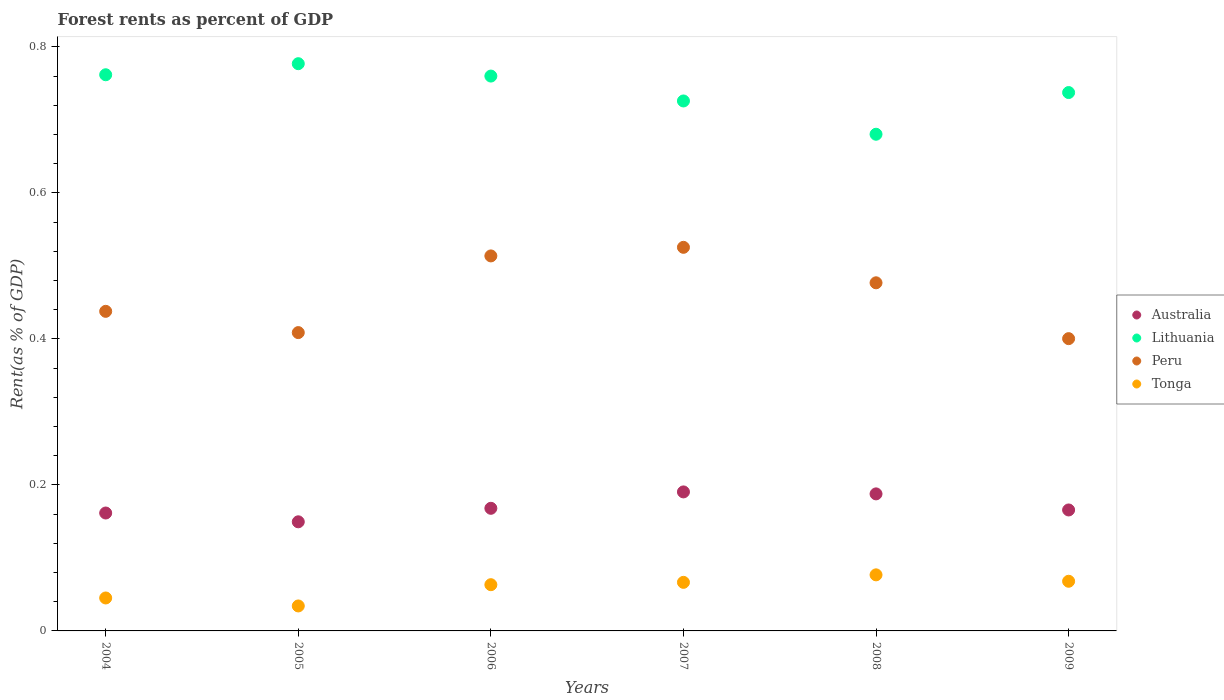What is the forest rent in Lithuania in 2009?
Provide a succinct answer. 0.74. Across all years, what is the maximum forest rent in Lithuania?
Provide a succinct answer. 0.78. Across all years, what is the minimum forest rent in Tonga?
Make the answer very short. 0.03. What is the total forest rent in Peru in the graph?
Offer a very short reply. 2.76. What is the difference between the forest rent in Australia in 2006 and that in 2008?
Give a very brief answer. -0.02. What is the difference between the forest rent in Tonga in 2006 and the forest rent in Peru in 2005?
Ensure brevity in your answer.  -0.35. What is the average forest rent in Lithuania per year?
Make the answer very short. 0.74. In the year 2006, what is the difference between the forest rent in Peru and forest rent in Lithuania?
Keep it short and to the point. -0.25. In how many years, is the forest rent in Lithuania greater than 0.56 %?
Keep it short and to the point. 6. What is the ratio of the forest rent in Australia in 2004 to that in 2007?
Provide a short and direct response. 0.85. Is the forest rent in Tonga in 2005 less than that in 2007?
Make the answer very short. Yes. Is the difference between the forest rent in Peru in 2004 and 2006 greater than the difference between the forest rent in Lithuania in 2004 and 2006?
Offer a terse response. No. What is the difference between the highest and the second highest forest rent in Australia?
Ensure brevity in your answer.  0. What is the difference between the highest and the lowest forest rent in Peru?
Your response must be concise. 0.13. In how many years, is the forest rent in Australia greater than the average forest rent in Australia taken over all years?
Offer a terse response. 2. Is the sum of the forest rent in Tonga in 2005 and 2009 greater than the maximum forest rent in Peru across all years?
Your answer should be compact. No. How many dotlines are there?
Offer a terse response. 4. How many years are there in the graph?
Your answer should be compact. 6. What is the difference between two consecutive major ticks on the Y-axis?
Your answer should be compact. 0.2. Are the values on the major ticks of Y-axis written in scientific E-notation?
Give a very brief answer. No. Does the graph contain grids?
Make the answer very short. No. Where does the legend appear in the graph?
Make the answer very short. Center right. What is the title of the graph?
Make the answer very short. Forest rents as percent of GDP. Does "Guam" appear as one of the legend labels in the graph?
Ensure brevity in your answer.  No. What is the label or title of the X-axis?
Your answer should be very brief. Years. What is the label or title of the Y-axis?
Your response must be concise. Rent(as % of GDP). What is the Rent(as % of GDP) of Australia in 2004?
Provide a short and direct response. 0.16. What is the Rent(as % of GDP) in Lithuania in 2004?
Your answer should be compact. 0.76. What is the Rent(as % of GDP) in Peru in 2004?
Your response must be concise. 0.44. What is the Rent(as % of GDP) in Tonga in 2004?
Your answer should be compact. 0.05. What is the Rent(as % of GDP) of Australia in 2005?
Your response must be concise. 0.15. What is the Rent(as % of GDP) of Lithuania in 2005?
Your answer should be compact. 0.78. What is the Rent(as % of GDP) in Peru in 2005?
Your answer should be very brief. 0.41. What is the Rent(as % of GDP) in Tonga in 2005?
Ensure brevity in your answer.  0.03. What is the Rent(as % of GDP) in Australia in 2006?
Provide a short and direct response. 0.17. What is the Rent(as % of GDP) of Lithuania in 2006?
Offer a terse response. 0.76. What is the Rent(as % of GDP) in Peru in 2006?
Offer a very short reply. 0.51. What is the Rent(as % of GDP) of Tonga in 2006?
Offer a very short reply. 0.06. What is the Rent(as % of GDP) in Australia in 2007?
Provide a short and direct response. 0.19. What is the Rent(as % of GDP) of Lithuania in 2007?
Keep it short and to the point. 0.73. What is the Rent(as % of GDP) of Peru in 2007?
Offer a terse response. 0.53. What is the Rent(as % of GDP) in Tonga in 2007?
Your answer should be very brief. 0.07. What is the Rent(as % of GDP) of Australia in 2008?
Ensure brevity in your answer.  0.19. What is the Rent(as % of GDP) of Lithuania in 2008?
Keep it short and to the point. 0.68. What is the Rent(as % of GDP) of Peru in 2008?
Make the answer very short. 0.48. What is the Rent(as % of GDP) in Tonga in 2008?
Ensure brevity in your answer.  0.08. What is the Rent(as % of GDP) in Australia in 2009?
Give a very brief answer. 0.17. What is the Rent(as % of GDP) in Lithuania in 2009?
Ensure brevity in your answer.  0.74. What is the Rent(as % of GDP) in Peru in 2009?
Provide a short and direct response. 0.4. What is the Rent(as % of GDP) in Tonga in 2009?
Offer a terse response. 0.07. Across all years, what is the maximum Rent(as % of GDP) of Australia?
Ensure brevity in your answer.  0.19. Across all years, what is the maximum Rent(as % of GDP) in Lithuania?
Offer a very short reply. 0.78. Across all years, what is the maximum Rent(as % of GDP) of Peru?
Offer a very short reply. 0.53. Across all years, what is the maximum Rent(as % of GDP) of Tonga?
Your answer should be very brief. 0.08. Across all years, what is the minimum Rent(as % of GDP) of Australia?
Give a very brief answer. 0.15. Across all years, what is the minimum Rent(as % of GDP) of Lithuania?
Ensure brevity in your answer.  0.68. Across all years, what is the minimum Rent(as % of GDP) of Peru?
Keep it short and to the point. 0.4. Across all years, what is the minimum Rent(as % of GDP) of Tonga?
Ensure brevity in your answer.  0.03. What is the total Rent(as % of GDP) of Australia in the graph?
Ensure brevity in your answer.  1.02. What is the total Rent(as % of GDP) of Lithuania in the graph?
Give a very brief answer. 4.44. What is the total Rent(as % of GDP) in Peru in the graph?
Provide a short and direct response. 2.76. What is the total Rent(as % of GDP) of Tonga in the graph?
Keep it short and to the point. 0.35. What is the difference between the Rent(as % of GDP) of Australia in 2004 and that in 2005?
Ensure brevity in your answer.  0.01. What is the difference between the Rent(as % of GDP) of Lithuania in 2004 and that in 2005?
Provide a succinct answer. -0.02. What is the difference between the Rent(as % of GDP) of Peru in 2004 and that in 2005?
Your response must be concise. 0.03. What is the difference between the Rent(as % of GDP) of Tonga in 2004 and that in 2005?
Provide a short and direct response. 0.01. What is the difference between the Rent(as % of GDP) in Australia in 2004 and that in 2006?
Your answer should be very brief. -0.01. What is the difference between the Rent(as % of GDP) in Lithuania in 2004 and that in 2006?
Your response must be concise. 0. What is the difference between the Rent(as % of GDP) in Peru in 2004 and that in 2006?
Your answer should be very brief. -0.08. What is the difference between the Rent(as % of GDP) in Tonga in 2004 and that in 2006?
Offer a terse response. -0.02. What is the difference between the Rent(as % of GDP) in Australia in 2004 and that in 2007?
Your answer should be very brief. -0.03. What is the difference between the Rent(as % of GDP) of Lithuania in 2004 and that in 2007?
Offer a very short reply. 0.04. What is the difference between the Rent(as % of GDP) of Peru in 2004 and that in 2007?
Provide a short and direct response. -0.09. What is the difference between the Rent(as % of GDP) of Tonga in 2004 and that in 2007?
Give a very brief answer. -0.02. What is the difference between the Rent(as % of GDP) of Australia in 2004 and that in 2008?
Provide a short and direct response. -0.03. What is the difference between the Rent(as % of GDP) in Lithuania in 2004 and that in 2008?
Offer a very short reply. 0.08. What is the difference between the Rent(as % of GDP) in Peru in 2004 and that in 2008?
Provide a succinct answer. -0.04. What is the difference between the Rent(as % of GDP) in Tonga in 2004 and that in 2008?
Your response must be concise. -0.03. What is the difference between the Rent(as % of GDP) of Australia in 2004 and that in 2009?
Your answer should be very brief. -0. What is the difference between the Rent(as % of GDP) in Lithuania in 2004 and that in 2009?
Give a very brief answer. 0.02. What is the difference between the Rent(as % of GDP) of Peru in 2004 and that in 2009?
Your answer should be compact. 0.04. What is the difference between the Rent(as % of GDP) in Tonga in 2004 and that in 2009?
Offer a very short reply. -0.02. What is the difference between the Rent(as % of GDP) of Australia in 2005 and that in 2006?
Provide a succinct answer. -0.02. What is the difference between the Rent(as % of GDP) in Lithuania in 2005 and that in 2006?
Ensure brevity in your answer.  0.02. What is the difference between the Rent(as % of GDP) in Peru in 2005 and that in 2006?
Make the answer very short. -0.1. What is the difference between the Rent(as % of GDP) in Tonga in 2005 and that in 2006?
Provide a succinct answer. -0.03. What is the difference between the Rent(as % of GDP) of Australia in 2005 and that in 2007?
Offer a terse response. -0.04. What is the difference between the Rent(as % of GDP) of Lithuania in 2005 and that in 2007?
Your answer should be compact. 0.05. What is the difference between the Rent(as % of GDP) of Peru in 2005 and that in 2007?
Your response must be concise. -0.12. What is the difference between the Rent(as % of GDP) of Tonga in 2005 and that in 2007?
Give a very brief answer. -0.03. What is the difference between the Rent(as % of GDP) in Australia in 2005 and that in 2008?
Your response must be concise. -0.04. What is the difference between the Rent(as % of GDP) of Lithuania in 2005 and that in 2008?
Your answer should be compact. 0.1. What is the difference between the Rent(as % of GDP) in Peru in 2005 and that in 2008?
Your response must be concise. -0.07. What is the difference between the Rent(as % of GDP) in Tonga in 2005 and that in 2008?
Your response must be concise. -0.04. What is the difference between the Rent(as % of GDP) in Australia in 2005 and that in 2009?
Give a very brief answer. -0.02. What is the difference between the Rent(as % of GDP) of Lithuania in 2005 and that in 2009?
Offer a very short reply. 0.04. What is the difference between the Rent(as % of GDP) in Peru in 2005 and that in 2009?
Make the answer very short. 0.01. What is the difference between the Rent(as % of GDP) in Tonga in 2005 and that in 2009?
Offer a terse response. -0.03. What is the difference between the Rent(as % of GDP) of Australia in 2006 and that in 2007?
Keep it short and to the point. -0.02. What is the difference between the Rent(as % of GDP) in Lithuania in 2006 and that in 2007?
Ensure brevity in your answer.  0.03. What is the difference between the Rent(as % of GDP) of Peru in 2006 and that in 2007?
Provide a succinct answer. -0.01. What is the difference between the Rent(as % of GDP) in Tonga in 2006 and that in 2007?
Ensure brevity in your answer.  -0. What is the difference between the Rent(as % of GDP) of Australia in 2006 and that in 2008?
Your response must be concise. -0.02. What is the difference between the Rent(as % of GDP) in Lithuania in 2006 and that in 2008?
Ensure brevity in your answer.  0.08. What is the difference between the Rent(as % of GDP) of Peru in 2006 and that in 2008?
Offer a terse response. 0.04. What is the difference between the Rent(as % of GDP) of Tonga in 2006 and that in 2008?
Give a very brief answer. -0.01. What is the difference between the Rent(as % of GDP) in Australia in 2006 and that in 2009?
Offer a terse response. 0. What is the difference between the Rent(as % of GDP) of Lithuania in 2006 and that in 2009?
Give a very brief answer. 0.02. What is the difference between the Rent(as % of GDP) of Peru in 2006 and that in 2009?
Your answer should be compact. 0.11. What is the difference between the Rent(as % of GDP) of Tonga in 2006 and that in 2009?
Offer a very short reply. -0. What is the difference between the Rent(as % of GDP) of Australia in 2007 and that in 2008?
Your answer should be compact. 0. What is the difference between the Rent(as % of GDP) in Lithuania in 2007 and that in 2008?
Offer a very short reply. 0.05. What is the difference between the Rent(as % of GDP) of Peru in 2007 and that in 2008?
Give a very brief answer. 0.05. What is the difference between the Rent(as % of GDP) of Tonga in 2007 and that in 2008?
Provide a succinct answer. -0.01. What is the difference between the Rent(as % of GDP) in Australia in 2007 and that in 2009?
Make the answer very short. 0.02. What is the difference between the Rent(as % of GDP) of Lithuania in 2007 and that in 2009?
Your response must be concise. -0.01. What is the difference between the Rent(as % of GDP) of Peru in 2007 and that in 2009?
Make the answer very short. 0.13. What is the difference between the Rent(as % of GDP) in Tonga in 2007 and that in 2009?
Provide a succinct answer. -0. What is the difference between the Rent(as % of GDP) in Australia in 2008 and that in 2009?
Your answer should be very brief. 0.02. What is the difference between the Rent(as % of GDP) in Lithuania in 2008 and that in 2009?
Provide a short and direct response. -0.06. What is the difference between the Rent(as % of GDP) of Peru in 2008 and that in 2009?
Keep it short and to the point. 0.08. What is the difference between the Rent(as % of GDP) in Tonga in 2008 and that in 2009?
Offer a very short reply. 0.01. What is the difference between the Rent(as % of GDP) in Australia in 2004 and the Rent(as % of GDP) in Lithuania in 2005?
Keep it short and to the point. -0.62. What is the difference between the Rent(as % of GDP) in Australia in 2004 and the Rent(as % of GDP) in Peru in 2005?
Provide a short and direct response. -0.25. What is the difference between the Rent(as % of GDP) in Australia in 2004 and the Rent(as % of GDP) in Tonga in 2005?
Your answer should be very brief. 0.13. What is the difference between the Rent(as % of GDP) of Lithuania in 2004 and the Rent(as % of GDP) of Peru in 2005?
Make the answer very short. 0.35. What is the difference between the Rent(as % of GDP) of Lithuania in 2004 and the Rent(as % of GDP) of Tonga in 2005?
Provide a short and direct response. 0.73. What is the difference between the Rent(as % of GDP) in Peru in 2004 and the Rent(as % of GDP) in Tonga in 2005?
Your response must be concise. 0.4. What is the difference between the Rent(as % of GDP) in Australia in 2004 and the Rent(as % of GDP) in Lithuania in 2006?
Provide a short and direct response. -0.6. What is the difference between the Rent(as % of GDP) in Australia in 2004 and the Rent(as % of GDP) in Peru in 2006?
Provide a succinct answer. -0.35. What is the difference between the Rent(as % of GDP) in Australia in 2004 and the Rent(as % of GDP) in Tonga in 2006?
Your answer should be very brief. 0.1. What is the difference between the Rent(as % of GDP) in Lithuania in 2004 and the Rent(as % of GDP) in Peru in 2006?
Ensure brevity in your answer.  0.25. What is the difference between the Rent(as % of GDP) of Lithuania in 2004 and the Rent(as % of GDP) of Tonga in 2006?
Keep it short and to the point. 0.7. What is the difference between the Rent(as % of GDP) in Peru in 2004 and the Rent(as % of GDP) in Tonga in 2006?
Your response must be concise. 0.37. What is the difference between the Rent(as % of GDP) of Australia in 2004 and the Rent(as % of GDP) of Lithuania in 2007?
Your answer should be very brief. -0.56. What is the difference between the Rent(as % of GDP) of Australia in 2004 and the Rent(as % of GDP) of Peru in 2007?
Offer a terse response. -0.36. What is the difference between the Rent(as % of GDP) in Australia in 2004 and the Rent(as % of GDP) in Tonga in 2007?
Your answer should be compact. 0.1. What is the difference between the Rent(as % of GDP) of Lithuania in 2004 and the Rent(as % of GDP) of Peru in 2007?
Provide a short and direct response. 0.24. What is the difference between the Rent(as % of GDP) in Lithuania in 2004 and the Rent(as % of GDP) in Tonga in 2007?
Keep it short and to the point. 0.7. What is the difference between the Rent(as % of GDP) in Peru in 2004 and the Rent(as % of GDP) in Tonga in 2007?
Your answer should be compact. 0.37. What is the difference between the Rent(as % of GDP) in Australia in 2004 and the Rent(as % of GDP) in Lithuania in 2008?
Your answer should be very brief. -0.52. What is the difference between the Rent(as % of GDP) of Australia in 2004 and the Rent(as % of GDP) of Peru in 2008?
Your response must be concise. -0.32. What is the difference between the Rent(as % of GDP) of Australia in 2004 and the Rent(as % of GDP) of Tonga in 2008?
Your answer should be compact. 0.08. What is the difference between the Rent(as % of GDP) of Lithuania in 2004 and the Rent(as % of GDP) of Peru in 2008?
Ensure brevity in your answer.  0.28. What is the difference between the Rent(as % of GDP) of Lithuania in 2004 and the Rent(as % of GDP) of Tonga in 2008?
Keep it short and to the point. 0.69. What is the difference between the Rent(as % of GDP) in Peru in 2004 and the Rent(as % of GDP) in Tonga in 2008?
Offer a terse response. 0.36. What is the difference between the Rent(as % of GDP) of Australia in 2004 and the Rent(as % of GDP) of Lithuania in 2009?
Your answer should be compact. -0.58. What is the difference between the Rent(as % of GDP) in Australia in 2004 and the Rent(as % of GDP) in Peru in 2009?
Keep it short and to the point. -0.24. What is the difference between the Rent(as % of GDP) in Australia in 2004 and the Rent(as % of GDP) in Tonga in 2009?
Your answer should be compact. 0.09. What is the difference between the Rent(as % of GDP) of Lithuania in 2004 and the Rent(as % of GDP) of Peru in 2009?
Ensure brevity in your answer.  0.36. What is the difference between the Rent(as % of GDP) of Lithuania in 2004 and the Rent(as % of GDP) of Tonga in 2009?
Give a very brief answer. 0.69. What is the difference between the Rent(as % of GDP) of Peru in 2004 and the Rent(as % of GDP) of Tonga in 2009?
Give a very brief answer. 0.37. What is the difference between the Rent(as % of GDP) of Australia in 2005 and the Rent(as % of GDP) of Lithuania in 2006?
Keep it short and to the point. -0.61. What is the difference between the Rent(as % of GDP) of Australia in 2005 and the Rent(as % of GDP) of Peru in 2006?
Ensure brevity in your answer.  -0.36. What is the difference between the Rent(as % of GDP) in Australia in 2005 and the Rent(as % of GDP) in Tonga in 2006?
Ensure brevity in your answer.  0.09. What is the difference between the Rent(as % of GDP) in Lithuania in 2005 and the Rent(as % of GDP) in Peru in 2006?
Keep it short and to the point. 0.26. What is the difference between the Rent(as % of GDP) of Lithuania in 2005 and the Rent(as % of GDP) of Tonga in 2006?
Provide a succinct answer. 0.71. What is the difference between the Rent(as % of GDP) in Peru in 2005 and the Rent(as % of GDP) in Tonga in 2006?
Provide a short and direct response. 0.35. What is the difference between the Rent(as % of GDP) of Australia in 2005 and the Rent(as % of GDP) of Lithuania in 2007?
Make the answer very short. -0.58. What is the difference between the Rent(as % of GDP) in Australia in 2005 and the Rent(as % of GDP) in Peru in 2007?
Make the answer very short. -0.38. What is the difference between the Rent(as % of GDP) in Australia in 2005 and the Rent(as % of GDP) in Tonga in 2007?
Your answer should be very brief. 0.08. What is the difference between the Rent(as % of GDP) in Lithuania in 2005 and the Rent(as % of GDP) in Peru in 2007?
Offer a terse response. 0.25. What is the difference between the Rent(as % of GDP) in Lithuania in 2005 and the Rent(as % of GDP) in Tonga in 2007?
Your response must be concise. 0.71. What is the difference between the Rent(as % of GDP) of Peru in 2005 and the Rent(as % of GDP) of Tonga in 2007?
Provide a succinct answer. 0.34. What is the difference between the Rent(as % of GDP) in Australia in 2005 and the Rent(as % of GDP) in Lithuania in 2008?
Make the answer very short. -0.53. What is the difference between the Rent(as % of GDP) of Australia in 2005 and the Rent(as % of GDP) of Peru in 2008?
Your answer should be very brief. -0.33. What is the difference between the Rent(as % of GDP) in Australia in 2005 and the Rent(as % of GDP) in Tonga in 2008?
Offer a terse response. 0.07. What is the difference between the Rent(as % of GDP) of Lithuania in 2005 and the Rent(as % of GDP) of Peru in 2008?
Your answer should be compact. 0.3. What is the difference between the Rent(as % of GDP) of Lithuania in 2005 and the Rent(as % of GDP) of Tonga in 2008?
Ensure brevity in your answer.  0.7. What is the difference between the Rent(as % of GDP) of Peru in 2005 and the Rent(as % of GDP) of Tonga in 2008?
Provide a succinct answer. 0.33. What is the difference between the Rent(as % of GDP) of Australia in 2005 and the Rent(as % of GDP) of Lithuania in 2009?
Give a very brief answer. -0.59. What is the difference between the Rent(as % of GDP) in Australia in 2005 and the Rent(as % of GDP) in Peru in 2009?
Give a very brief answer. -0.25. What is the difference between the Rent(as % of GDP) in Australia in 2005 and the Rent(as % of GDP) in Tonga in 2009?
Your response must be concise. 0.08. What is the difference between the Rent(as % of GDP) of Lithuania in 2005 and the Rent(as % of GDP) of Peru in 2009?
Ensure brevity in your answer.  0.38. What is the difference between the Rent(as % of GDP) in Lithuania in 2005 and the Rent(as % of GDP) in Tonga in 2009?
Ensure brevity in your answer.  0.71. What is the difference between the Rent(as % of GDP) in Peru in 2005 and the Rent(as % of GDP) in Tonga in 2009?
Your answer should be compact. 0.34. What is the difference between the Rent(as % of GDP) in Australia in 2006 and the Rent(as % of GDP) in Lithuania in 2007?
Provide a short and direct response. -0.56. What is the difference between the Rent(as % of GDP) of Australia in 2006 and the Rent(as % of GDP) of Peru in 2007?
Provide a short and direct response. -0.36. What is the difference between the Rent(as % of GDP) of Australia in 2006 and the Rent(as % of GDP) of Tonga in 2007?
Provide a succinct answer. 0.1. What is the difference between the Rent(as % of GDP) in Lithuania in 2006 and the Rent(as % of GDP) in Peru in 2007?
Provide a succinct answer. 0.23. What is the difference between the Rent(as % of GDP) in Lithuania in 2006 and the Rent(as % of GDP) in Tonga in 2007?
Make the answer very short. 0.69. What is the difference between the Rent(as % of GDP) in Peru in 2006 and the Rent(as % of GDP) in Tonga in 2007?
Provide a short and direct response. 0.45. What is the difference between the Rent(as % of GDP) in Australia in 2006 and the Rent(as % of GDP) in Lithuania in 2008?
Offer a very short reply. -0.51. What is the difference between the Rent(as % of GDP) of Australia in 2006 and the Rent(as % of GDP) of Peru in 2008?
Offer a terse response. -0.31. What is the difference between the Rent(as % of GDP) in Australia in 2006 and the Rent(as % of GDP) in Tonga in 2008?
Your answer should be very brief. 0.09. What is the difference between the Rent(as % of GDP) of Lithuania in 2006 and the Rent(as % of GDP) of Peru in 2008?
Provide a succinct answer. 0.28. What is the difference between the Rent(as % of GDP) of Lithuania in 2006 and the Rent(as % of GDP) of Tonga in 2008?
Your answer should be compact. 0.68. What is the difference between the Rent(as % of GDP) in Peru in 2006 and the Rent(as % of GDP) in Tonga in 2008?
Keep it short and to the point. 0.44. What is the difference between the Rent(as % of GDP) in Australia in 2006 and the Rent(as % of GDP) in Lithuania in 2009?
Provide a short and direct response. -0.57. What is the difference between the Rent(as % of GDP) in Australia in 2006 and the Rent(as % of GDP) in Peru in 2009?
Ensure brevity in your answer.  -0.23. What is the difference between the Rent(as % of GDP) of Australia in 2006 and the Rent(as % of GDP) of Tonga in 2009?
Your response must be concise. 0.1. What is the difference between the Rent(as % of GDP) in Lithuania in 2006 and the Rent(as % of GDP) in Peru in 2009?
Make the answer very short. 0.36. What is the difference between the Rent(as % of GDP) in Lithuania in 2006 and the Rent(as % of GDP) in Tonga in 2009?
Keep it short and to the point. 0.69. What is the difference between the Rent(as % of GDP) of Peru in 2006 and the Rent(as % of GDP) of Tonga in 2009?
Ensure brevity in your answer.  0.45. What is the difference between the Rent(as % of GDP) in Australia in 2007 and the Rent(as % of GDP) in Lithuania in 2008?
Ensure brevity in your answer.  -0.49. What is the difference between the Rent(as % of GDP) of Australia in 2007 and the Rent(as % of GDP) of Peru in 2008?
Your answer should be compact. -0.29. What is the difference between the Rent(as % of GDP) in Australia in 2007 and the Rent(as % of GDP) in Tonga in 2008?
Your answer should be very brief. 0.11. What is the difference between the Rent(as % of GDP) of Lithuania in 2007 and the Rent(as % of GDP) of Peru in 2008?
Make the answer very short. 0.25. What is the difference between the Rent(as % of GDP) in Lithuania in 2007 and the Rent(as % of GDP) in Tonga in 2008?
Provide a succinct answer. 0.65. What is the difference between the Rent(as % of GDP) of Peru in 2007 and the Rent(as % of GDP) of Tonga in 2008?
Keep it short and to the point. 0.45. What is the difference between the Rent(as % of GDP) of Australia in 2007 and the Rent(as % of GDP) of Lithuania in 2009?
Your answer should be very brief. -0.55. What is the difference between the Rent(as % of GDP) of Australia in 2007 and the Rent(as % of GDP) of Peru in 2009?
Keep it short and to the point. -0.21. What is the difference between the Rent(as % of GDP) in Australia in 2007 and the Rent(as % of GDP) in Tonga in 2009?
Your answer should be very brief. 0.12. What is the difference between the Rent(as % of GDP) in Lithuania in 2007 and the Rent(as % of GDP) in Peru in 2009?
Your answer should be very brief. 0.33. What is the difference between the Rent(as % of GDP) in Lithuania in 2007 and the Rent(as % of GDP) in Tonga in 2009?
Provide a succinct answer. 0.66. What is the difference between the Rent(as % of GDP) of Peru in 2007 and the Rent(as % of GDP) of Tonga in 2009?
Keep it short and to the point. 0.46. What is the difference between the Rent(as % of GDP) in Australia in 2008 and the Rent(as % of GDP) in Lithuania in 2009?
Give a very brief answer. -0.55. What is the difference between the Rent(as % of GDP) in Australia in 2008 and the Rent(as % of GDP) in Peru in 2009?
Give a very brief answer. -0.21. What is the difference between the Rent(as % of GDP) in Australia in 2008 and the Rent(as % of GDP) in Tonga in 2009?
Give a very brief answer. 0.12. What is the difference between the Rent(as % of GDP) in Lithuania in 2008 and the Rent(as % of GDP) in Peru in 2009?
Provide a short and direct response. 0.28. What is the difference between the Rent(as % of GDP) of Lithuania in 2008 and the Rent(as % of GDP) of Tonga in 2009?
Your answer should be very brief. 0.61. What is the difference between the Rent(as % of GDP) in Peru in 2008 and the Rent(as % of GDP) in Tonga in 2009?
Provide a short and direct response. 0.41. What is the average Rent(as % of GDP) of Australia per year?
Your response must be concise. 0.17. What is the average Rent(as % of GDP) in Lithuania per year?
Provide a short and direct response. 0.74. What is the average Rent(as % of GDP) of Peru per year?
Ensure brevity in your answer.  0.46. What is the average Rent(as % of GDP) of Tonga per year?
Keep it short and to the point. 0.06. In the year 2004, what is the difference between the Rent(as % of GDP) of Australia and Rent(as % of GDP) of Lithuania?
Keep it short and to the point. -0.6. In the year 2004, what is the difference between the Rent(as % of GDP) in Australia and Rent(as % of GDP) in Peru?
Provide a short and direct response. -0.28. In the year 2004, what is the difference between the Rent(as % of GDP) of Australia and Rent(as % of GDP) of Tonga?
Your answer should be very brief. 0.12. In the year 2004, what is the difference between the Rent(as % of GDP) in Lithuania and Rent(as % of GDP) in Peru?
Offer a very short reply. 0.32. In the year 2004, what is the difference between the Rent(as % of GDP) in Lithuania and Rent(as % of GDP) in Tonga?
Your answer should be compact. 0.72. In the year 2004, what is the difference between the Rent(as % of GDP) of Peru and Rent(as % of GDP) of Tonga?
Make the answer very short. 0.39. In the year 2005, what is the difference between the Rent(as % of GDP) in Australia and Rent(as % of GDP) in Lithuania?
Give a very brief answer. -0.63. In the year 2005, what is the difference between the Rent(as % of GDP) in Australia and Rent(as % of GDP) in Peru?
Make the answer very short. -0.26. In the year 2005, what is the difference between the Rent(as % of GDP) of Australia and Rent(as % of GDP) of Tonga?
Your response must be concise. 0.12. In the year 2005, what is the difference between the Rent(as % of GDP) in Lithuania and Rent(as % of GDP) in Peru?
Ensure brevity in your answer.  0.37. In the year 2005, what is the difference between the Rent(as % of GDP) of Lithuania and Rent(as % of GDP) of Tonga?
Offer a terse response. 0.74. In the year 2005, what is the difference between the Rent(as % of GDP) of Peru and Rent(as % of GDP) of Tonga?
Give a very brief answer. 0.37. In the year 2006, what is the difference between the Rent(as % of GDP) of Australia and Rent(as % of GDP) of Lithuania?
Offer a very short reply. -0.59. In the year 2006, what is the difference between the Rent(as % of GDP) of Australia and Rent(as % of GDP) of Peru?
Make the answer very short. -0.35. In the year 2006, what is the difference between the Rent(as % of GDP) in Australia and Rent(as % of GDP) in Tonga?
Give a very brief answer. 0.1. In the year 2006, what is the difference between the Rent(as % of GDP) of Lithuania and Rent(as % of GDP) of Peru?
Provide a succinct answer. 0.25. In the year 2006, what is the difference between the Rent(as % of GDP) in Lithuania and Rent(as % of GDP) in Tonga?
Your answer should be compact. 0.7. In the year 2006, what is the difference between the Rent(as % of GDP) in Peru and Rent(as % of GDP) in Tonga?
Provide a short and direct response. 0.45. In the year 2007, what is the difference between the Rent(as % of GDP) in Australia and Rent(as % of GDP) in Lithuania?
Offer a terse response. -0.54. In the year 2007, what is the difference between the Rent(as % of GDP) of Australia and Rent(as % of GDP) of Peru?
Offer a terse response. -0.34. In the year 2007, what is the difference between the Rent(as % of GDP) of Australia and Rent(as % of GDP) of Tonga?
Give a very brief answer. 0.12. In the year 2007, what is the difference between the Rent(as % of GDP) in Lithuania and Rent(as % of GDP) in Peru?
Offer a terse response. 0.2. In the year 2007, what is the difference between the Rent(as % of GDP) in Lithuania and Rent(as % of GDP) in Tonga?
Provide a succinct answer. 0.66. In the year 2007, what is the difference between the Rent(as % of GDP) of Peru and Rent(as % of GDP) of Tonga?
Offer a terse response. 0.46. In the year 2008, what is the difference between the Rent(as % of GDP) of Australia and Rent(as % of GDP) of Lithuania?
Provide a short and direct response. -0.49. In the year 2008, what is the difference between the Rent(as % of GDP) in Australia and Rent(as % of GDP) in Peru?
Give a very brief answer. -0.29. In the year 2008, what is the difference between the Rent(as % of GDP) in Australia and Rent(as % of GDP) in Tonga?
Your answer should be compact. 0.11. In the year 2008, what is the difference between the Rent(as % of GDP) of Lithuania and Rent(as % of GDP) of Peru?
Ensure brevity in your answer.  0.2. In the year 2008, what is the difference between the Rent(as % of GDP) of Lithuania and Rent(as % of GDP) of Tonga?
Your answer should be compact. 0.6. In the year 2008, what is the difference between the Rent(as % of GDP) in Peru and Rent(as % of GDP) in Tonga?
Keep it short and to the point. 0.4. In the year 2009, what is the difference between the Rent(as % of GDP) of Australia and Rent(as % of GDP) of Lithuania?
Offer a terse response. -0.57. In the year 2009, what is the difference between the Rent(as % of GDP) of Australia and Rent(as % of GDP) of Peru?
Make the answer very short. -0.23. In the year 2009, what is the difference between the Rent(as % of GDP) of Australia and Rent(as % of GDP) of Tonga?
Provide a succinct answer. 0.1. In the year 2009, what is the difference between the Rent(as % of GDP) of Lithuania and Rent(as % of GDP) of Peru?
Your response must be concise. 0.34. In the year 2009, what is the difference between the Rent(as % of GDP) in Lithuania and Rent(as % of GDP) in Tonga?
Provide a short and direct response. 0.67. In the year 2009, what is the difference between the Rent(as % of GDP) in Peru and Rent(as % of GDP) in Tonga?
Your answer should be very brief. 0.33. What is the ratio of the Rent(as % of GDP) of Australia in 2004 to that in 2005?
Offer a very short reply. 1.08. What is the ratio of the Rent(as % of GDP) in Lithuania in 2004 to that in 2005?
Give a very brief answer. 0.98. What is the ratio of the Rent(as % of GDP) in Peru in 2004 to that in 2005?
Your answer should be very brief. 1.07. What is the ratio of the Rent(as % of GDP) of Tonga in 2004 to that in 2005?
Keep it short and to the point. 1.32. What is the ratio of the Rent(as % of GDP) of Australia in 2004 to that in 2006?
Your answer should be compact. 0.96. What is the ratio of the Rent(as % of GDP) in Lithuania in 2004 to that in 2006?
Make the answer very short. 1. What is the ratio of the Rent(as % of GDP) of Peru in 2004 to that in 2006?
Your answer should be compact. 0.85. What is the ratio of the Rent(as % of GDP) of Tonga in 2004 to that in 2006?
Your answer should be compact. 0.71. What is the ratio of the Rent(as % of GDP) in Australia in 2004 to that in 2007?
Your answer should be very brief. 0.85. What is the ratio of the Rent(as % of GDP) of Lithuania in 2004 to that in 2007?
Provide a short and direct response. 1.05. What is the ratio of the Rent(as % of GDP) in Peru in 2004 to that in 2007?
Make the answer very short. 0.83. What is the ratio of the Rent(as % of GDP) in Tonga in 2004 to that in 2007?
Your answer should be compact. 0.68. What is the ratio of the Rent(as % of GDP) of Australia in 2004 to that in 2008?
Provide a short and direct response. 0.86. What is the ratio of the Rent(as % of GDP) of Lithuania in 2004 to that in 2008?
Your response must be concise. 1.12. What is the ratio of the Rent(as % of GDP) in Peru in 2004 to that in 2008?
Give a very brief answer. 0.92. What is the ratio of the Rent(as % of GDP) in Tonga in 2004 to that in 2008?
Provide a short and direct response. 0.59. What is the ratio of the Rent(as % of GDP) of Australia in 2004 to that in 2009?
Offer a very short reply. 0.97. What is the ratio of the Rent(as % of GDP) of Lithuania in 2004 to that in 2009?
Your answer should be very brief. 1.03. What is the ratio of the Rent(as % of GDP) of Peru in 2004 to that in 2009?
Provide a succinct answer. 1.09. What is the ratio of the Rent(as % of GDP) in Tonga in 2004 to that in 2009?
Provide a succinct answer. 0.66. What is the ratio of the Rent(as % of GDP) of Australia in 2005 to that in 2006?
Your response must be concise. 0.89. What is the ratio of the Rent(as % of GDP) of Lithuania in 2005 to that in 2006?
Make the answer very short. 1.02. What is the ratio of the Rent(as % of GDP) of Peru in 2005 to that in 2006?
Keep it short and to the point. 0.8. What is the ratio of the Rent(as % of GDP) in Tonga in 2005 to that in 2006?
Provide a short and direct response. 0.54. What is the ratio of the Rent(as % of GDP) of Australia in 2005 to that in 2007?
Offer a very short reply. 0.78. What is the ratio of the Rent(as % of GDP) of Lithuania in 2005 to that in 2007?
Make the answer very short. 1.07. What is the ratio of the Rent(as % of GDP) in Peru in 2005 to that in 2007?
Your answer should be compact. 0.78. What is the ratio of the Rent(as % of GDP) of Tonga in 2005 to that in 2007?
Provide a succinct answer. 0.51. What is the ratio of the Rent(as % of GDP) of Australia in 2005 to that in 2008?
Provide a succinct answer. 0.8. What is the ratio of the Rent(as % of GDP) in Lithuania in 2005 to that in 2008?
Your answer should be very brief. 1.14. What is the ratio of the Rent(as % of GDP) of Peru in 2005 to that in 2008?
Offer a terse response. 0.86. What is the ratio of the Rent(as % of GDP) of Tonga in 2005 to that in 2008?
Give a very brief answer. 0.45. What is the ratio of the Rent(as % of GDP) in Australia in 2005 to that in 2009?
Offer a very short reply. 0.9. What is the ratio of the Rent(as % of GDP) in Lithuania in 2005 to that in 2009?
Ensure brevity in your answer.  1.05. What is the ratio of the Rent(as % of GDP) in Peru in 2005 to that in 2009?
Your answer should be very brief. 1.02. What is the ratio of the Rent(as % of GDP) of Tonga in 2005 to that in 2009?
Your answer should be very brief. 0.5. What is the ratio of the Rent(as % of GDP) in Australia in 2006 to that in 2007?
Offer a very short reply. 0.88. What is the ratio of the Rent(as % of GDP) of Lithuania in 2006 to that in 2007?
Your answer should be very brief. 1.05. What is the ratio of the Rent(as % of GDP) in Peru in 2006 to that in 2007?
Your answer should be very brief. 0.98. What is the ratio of the Rent(as % of GDP) in Tonga in 2006 to that in 2007?
Provide a succinct answer. 0.95. What is the ratio of the Rent(as % of GDP) of Australia in 2006 to that in 2008?
Give a very brief answer. 0.89. What is the ratio of the Rent(as % of GDP) of Lithuania in 2006 to that in 2008?
Offer a very short reply. 1.12. What is the ratio of the Rent(as % of GDP) in Peru in 2006 to that in 2008?
Offer a very short reply. 1.08. What is the ratio of the Rent(as % of GDP) in Tonga in 2006 to that in 2008?
Make the answer very short. 0.82. What is the ratio of the Rent(as % of GDP) of Australia in 2006 to that in 2009?
Your response must be concise. 1.01. What is the ratio of the Rent(as % of GDP) in Lithuania in 2006 to that in 2009?
Make the answer very short. 1.03. What is the ratio of the Rent(as % of GDP) of Peru in 2006 to that in 2009?
Your response must be concise. 1.28. What is the ratio of the Rent(as % of GDP) in Tonga in 2006 to that in 2009?
Ensure brevity in your answer.  0.93. What is the ratio of the Rent(as % of GDP) in Australia in 2007 to that in 2008?
Provide a succinct answer. 1.01. What is the ratio of the Rent(as % of GDP) of Lithuania in 2007 to that in 2008?
Your response must be concise. 1.07. What is the ratio of the Rent(as % of GDP) in Peru in 2007 to that in 2008?
Offer a terse response. 1.1. What is the ratio of the Rent(as % of GDP) of Tonga in 2007 to that in 2008?
Your response must be concise. 0.87. What is the ratio of the Rent(as % of GDP) of Australia in 2007 to that in 2009?
Give a very brief answer. 1.15. What is the ratio of the Rent(as % of GDP) in Lithuania in 2007 to that in 2009?
Offer a very short reply. 0.98. What is the ratio of the Rent(as % of GDP) of Peru in 2007 to that in 2009?
Provide a succinct answer. 1.31. What is the ratio of the Rent(as % of GDP) of Tonga in 2007 to that in 2009?
Offer a terse response. 0.98. What is the ratio of the Rent(as % of GDP) of Australia in 2008 to that in 2009?
Keep it short and to the point. 1.13. What is the ratio of the Rent(as % of GDP) in Lithuania in 2008 to that in 2009?
Your response must be concise. 0.92. What is the ratio of the Rent(as % of GDP) in Peru in 2008 to that in 2009?
Ensure brevity in your answer.  1.19. What is the ratio of the Rent(as % of GDP) in Tonga in 2008 to that in 2009?
Provide a short and direct response. 1.13. What is the difference between the highest and the second highest Rent(as % of GDP) of Australia?
Provide a short and direct response. 0. What is the difference between the highest and the second highest Rent(as % of GDP) of Lithuania?
Ensure brevity in your answer.  0.02. What is the difference between the highest and the second highest Rent(as % of GDP) of Peru?
Your answer should be compact. 0.01. What is the difference between the highest and the second highest Rent(as % of GDP) in Tonga?
Provide a succinct answer. 0.01. What is the difference between the highest and the lowest Rent(as % of GDP) of Australia?
Ensure brevity in your answer.  0.04. What is the difference between the highest and the lowest Rent(as % of GDP) in Lithuania?
Offer a very short reply. 0.1. What is the difference between the highest and the lowest Rent(as % of GDP) in Peru?
Provide a short and direct response. 0.13. What is the difference between the highest and the lowest Rent(as % of GDP) of Tonga?
Offer a very short reply. 0.04. 